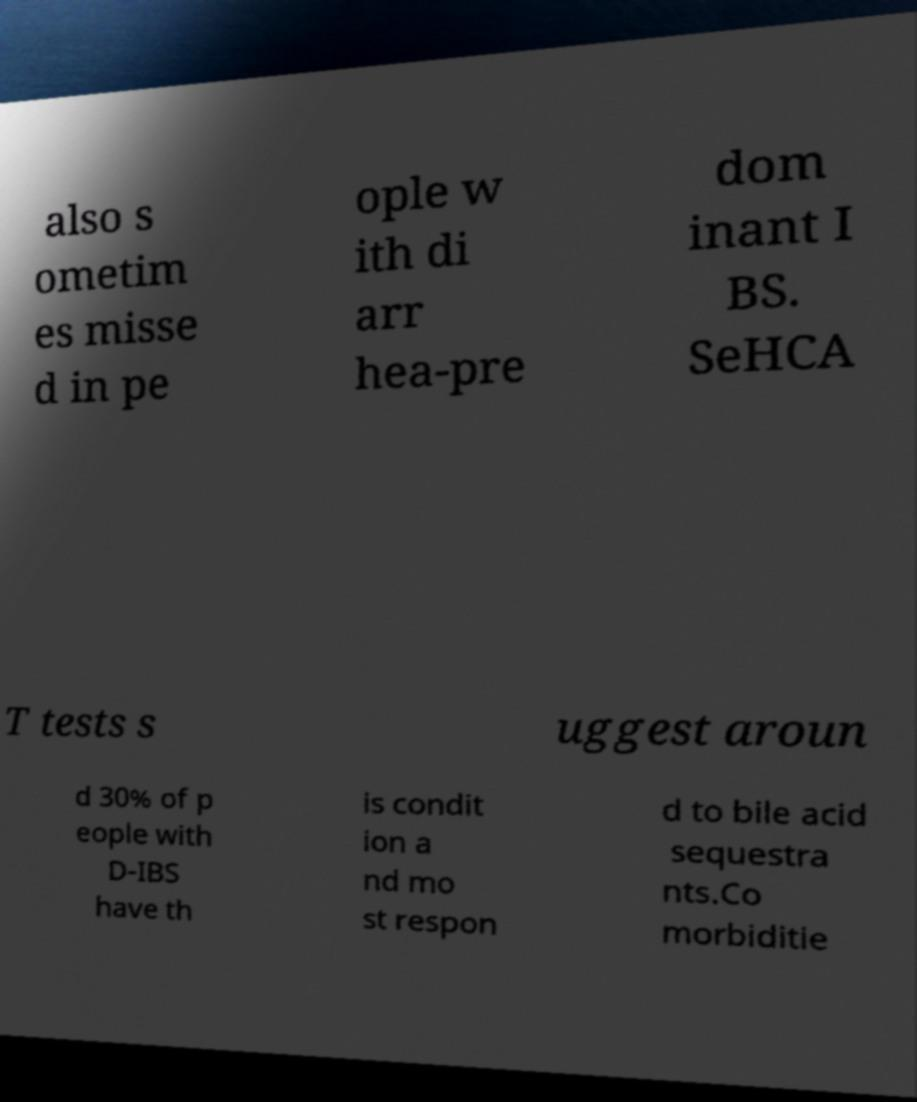I need the written content from this picture converted into text. Can you do that? also s ometim es misse d in pe ople w ith di arr hea-pre dom inant I BS. SeHCA T tests s uggest aroun d 30% of p eople with D-IBS have th is condit ion a nd mo st respon d to bile acid sequestra nts.Co morbiditie 